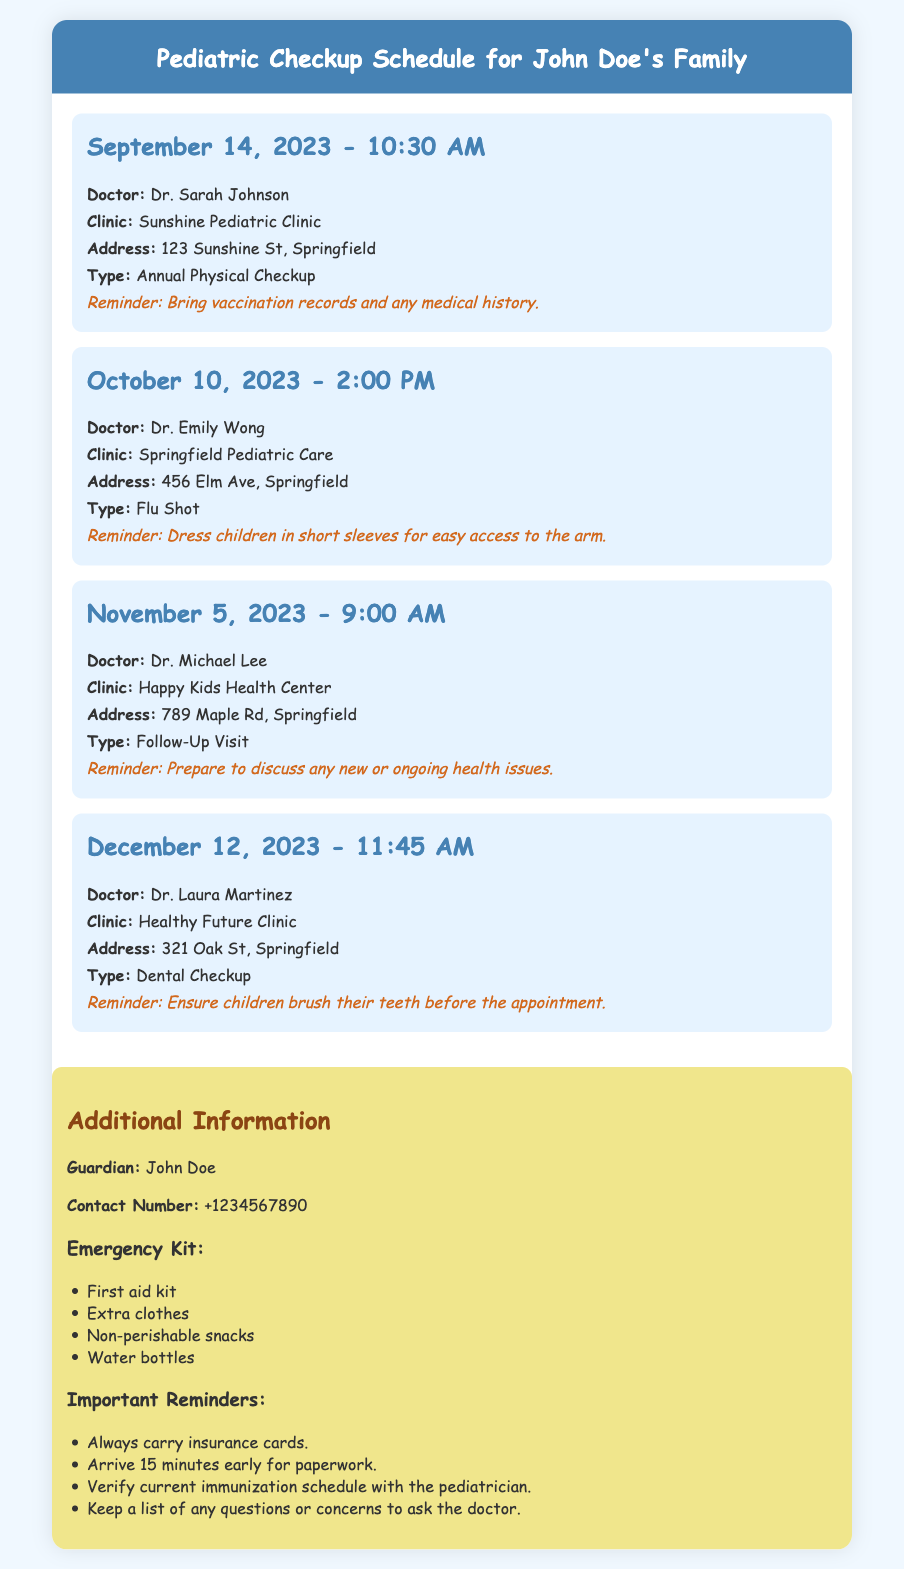What is the date of the first appointment? The first appointment is listed with its specific date in the document, which is September 14, 2023.
Answer: September 14, 2023 Who is the doctor for the dental checkup? The document specifies that the dental checkup is with Dr. Laura Martinez.
Answer: Dr. Laura Martinez What type of appointment is scheduled for October 10, 2023? The document lists the type of appointment scheduled for that date as a Flu Shot.
Answer: Flu Shot How many appointments are scheduled in total? By counting the number of appointments listed in the document, there are a total of four appointments scheduled.
Answer: Four What is the address of the clinic for the annual physical checkup? The document provides the specific address for the annual physical checkup as 123 Sunshine St, Springfield.
Answer: 123 Sunshine St, Springfield What reminder should be followed for the follow-up visit? The document includes a specific reminder that states to prepare to discuss any new or ongoing health issues for the follow-up visit.
Answer: Prepare to discuss any new or ongoing health issues What is the guardian's contact number? The document provides the guardian's contact number as part of the additional information.
Answer: +1234567890 What should be included in the emergency kit? The document lists several items in the emergency kit, one of which is a first aid kit.
Answer: First aid kit What time is the appointment on November 5, 2023? The appointment on that date is listed at 9:00 AM in the document.
Answer: 9:00 AM 